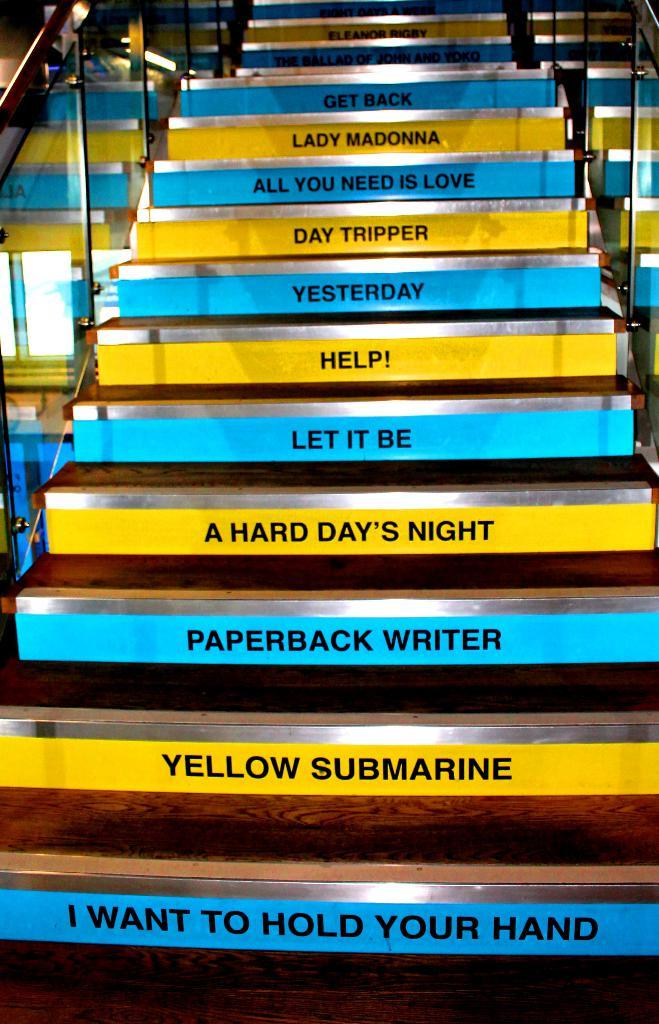<image>
Provide a brief description of the given image. A set of stairs has Beatles songs on the risers, including Let It Be. 